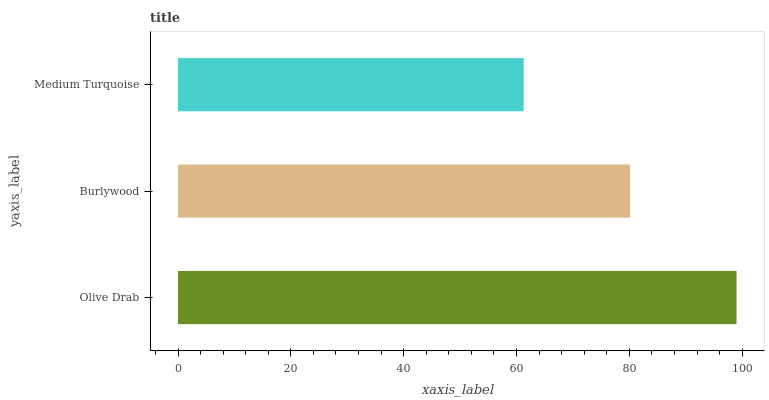Is Medium Turquoise the minimum?
Answer yes or no. Yes. Is Olive Drab the maximum?
Answer yes or no. Yes. Is Burlywood the minimum?
Answer yes or no. No. Is Burlywood the maximum?
Answer yes or no. No. Is Olive Drab greater than Burlywood?
Answer yes or no. Yes. Is Burlywood less than Olive Drab?
Answer yes or no. Yes. Is Burlywood greater than Olive Drab?
Answer yes or no. No. Is Olive Drab less than Burlywood?
Answer yes or no. No. Is Burlywood the high median?
Answer yes or no. Yes. Is Burlywood the low median?
Answer yes or no. Yes. Is Olive Drab the high median?
Answer yes or no. No. Is Medium Turquoise the low median?
Answer yes or no. No. 